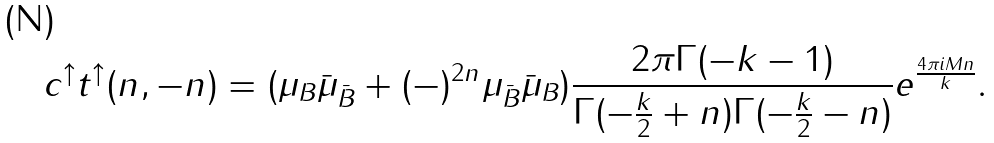<formula> <loc_0><loc_0><loc_500><loc_500>c ^ { \uparrow } t ^ { \uparrow } ( n , - n ) = ( \mu _ { B } \bar { \mu } _ { \bar { B } } + ( - ) ^ { 2 n } \mu _ { \bar { B } } \bar { \mu } _ { B } ) \frac { 2 \pi \Gamma ( - k - 1 ) } { \Gamma ( - \frac { k } { 2 } + n ) \Gamma ( - \frac { k } { 2 } - n ) } e ^ { \frac { 4 \pi i M n } { k } } .</formula> 